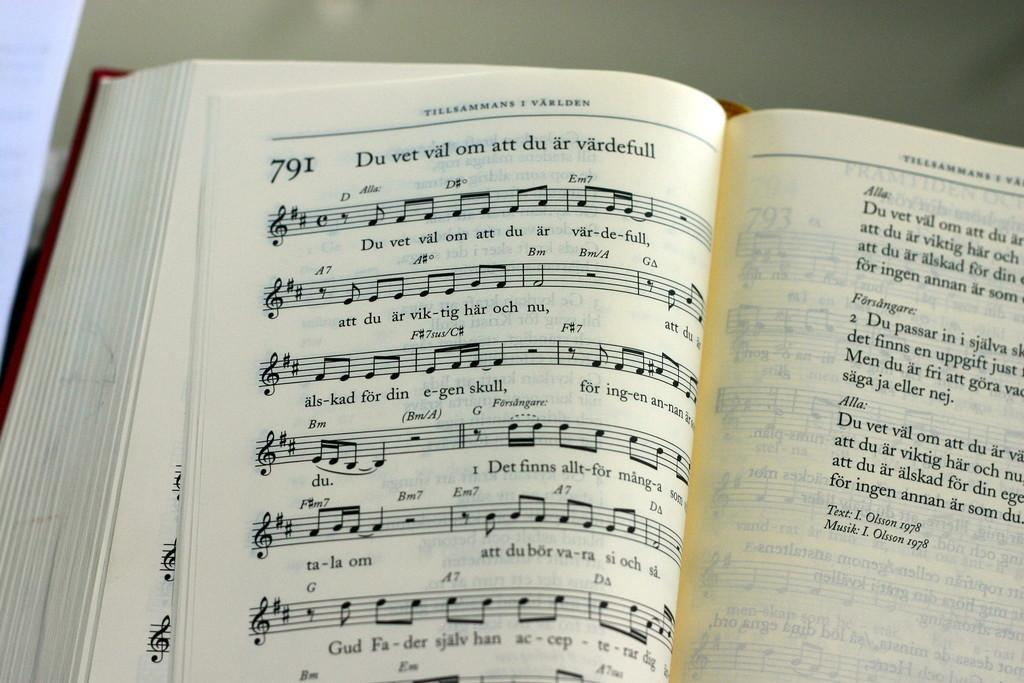<image>
Write a terse but informative summary of the picture. Music notation and lyrics for Du vet om att du ar vardefull. 